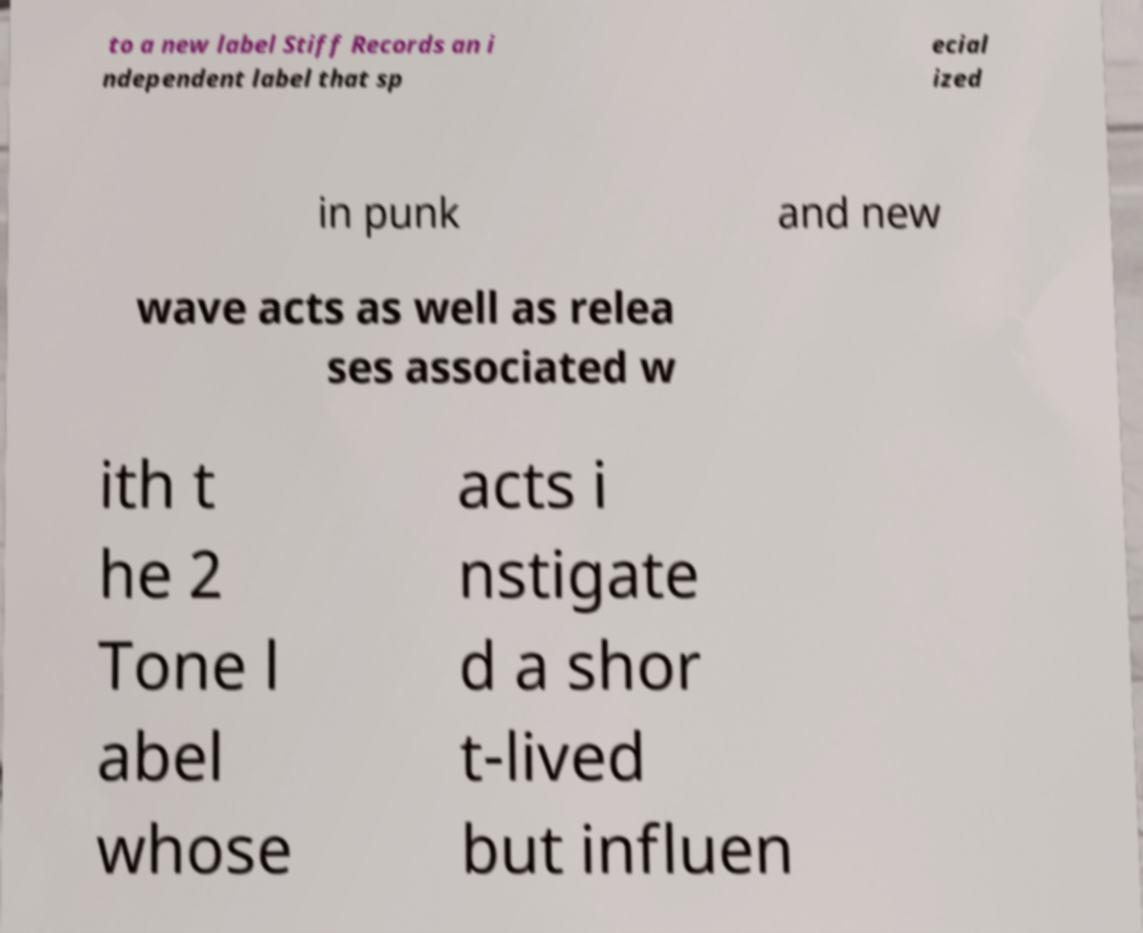Please read and relay the text visible in this image. What does it say? to a new label Stiff Records an i ndependent label that sp ecial ized in punk and new wave acts as well as relea ses associated w ith t he 2 Tone l abel whose acts i nstigate d a shor t-lived but influen 